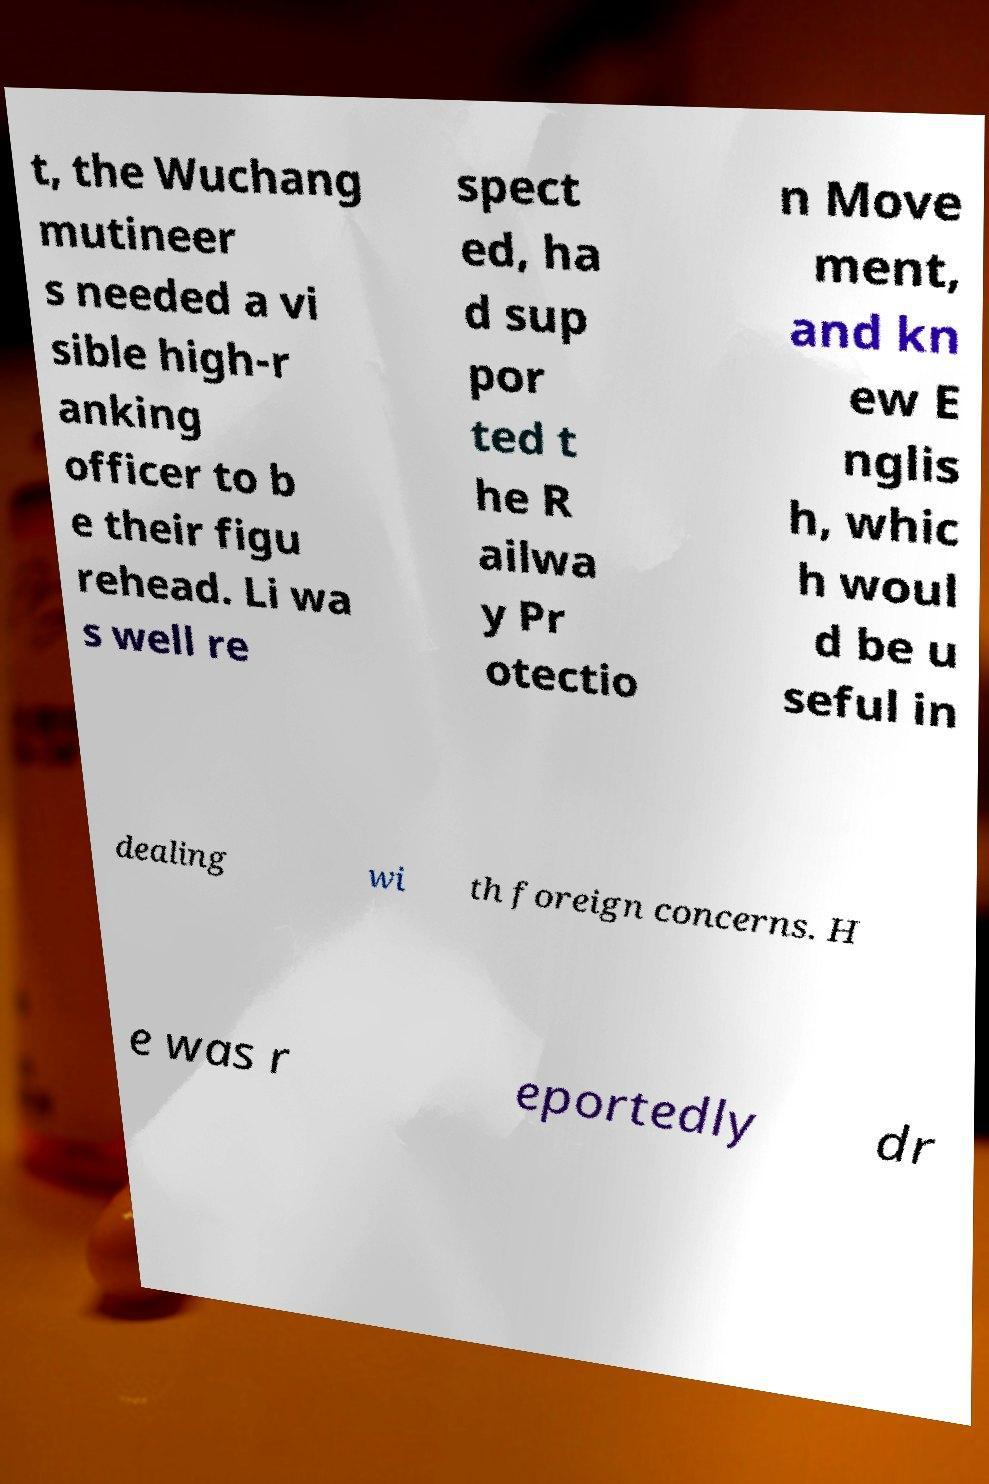Can you read and provide the text displayed in the image?This photo seems to have some interesting text. Can you extract and type it out for me? t, the Wuchang mutineer s needed a vi sible high-r anking officer to b e their figu rehead. Li wa s well re spect ed, ha d sup por ted t he R ailwa y Pr otectio n Move ment, and kn ew E nglis h, whic h woul d be u seful in dealing wi th foreign concerns. H e was r eportedly dr 